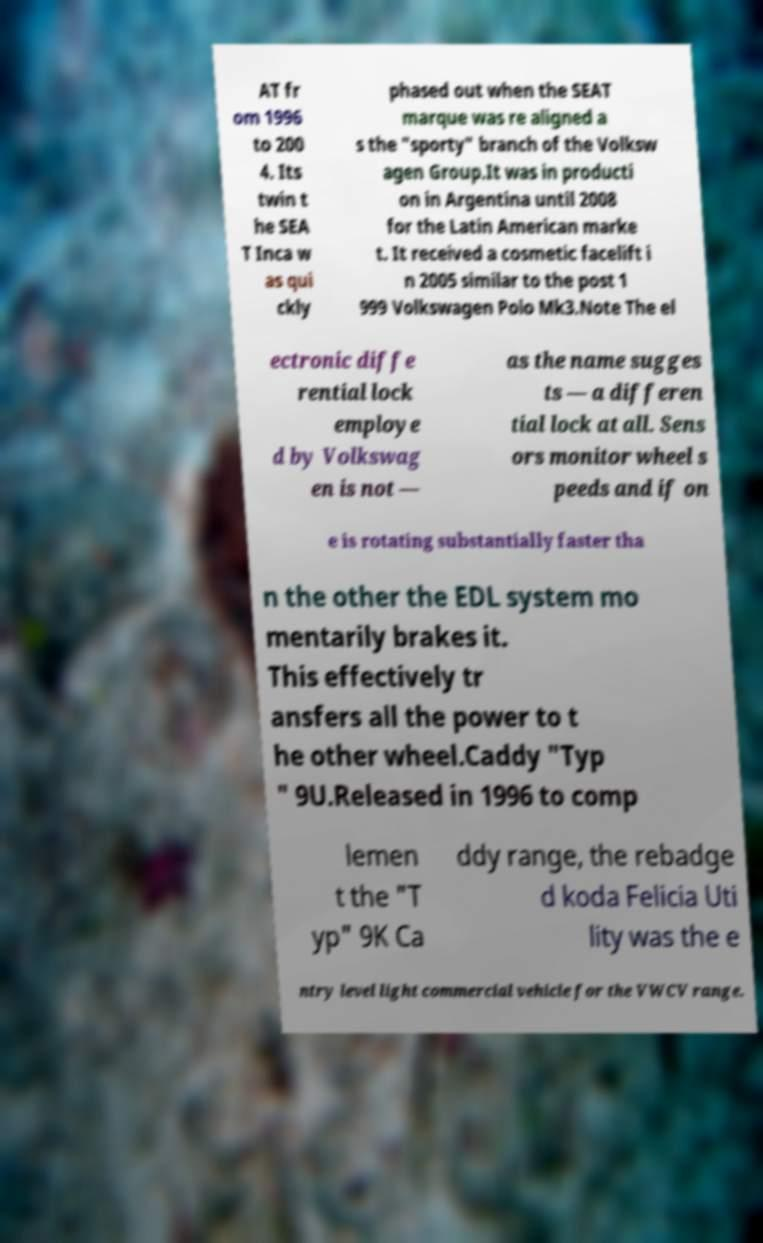I need the written content from this picture converted into text. Can you do that? AT fr om 1996 to 200 4. Its twin t he SEA T Inca w as qui ckly phased out when the SEAT marque was re aligned a s the "sporty" branch of the Volksw agen Group.It was in producti on in Argentina until 2008 for the Latin American marke t. It received a cosmetic facelift i n 2005 similar to the post 1 999 Volkswagen Polo Mk3.Note The el ectronic diffe rential lock employe d by Volkswag en is not — as the name sugges ts — a differen tial lock at all. Sens ors monitor wheel s peeds and if on e is rotating substantially faster tha n the other the EDL system mo mentarily brakes it. This effectively tr ansfers all the power to t he other wheel.Caddy "Typ " 9U.Released in 1996 to comp lemen t the "T yp" 9K Ca ddy range, the rebadge d koda Felicia Uti lity was the e ntry level light commercial vehicle for the VWCV range. 